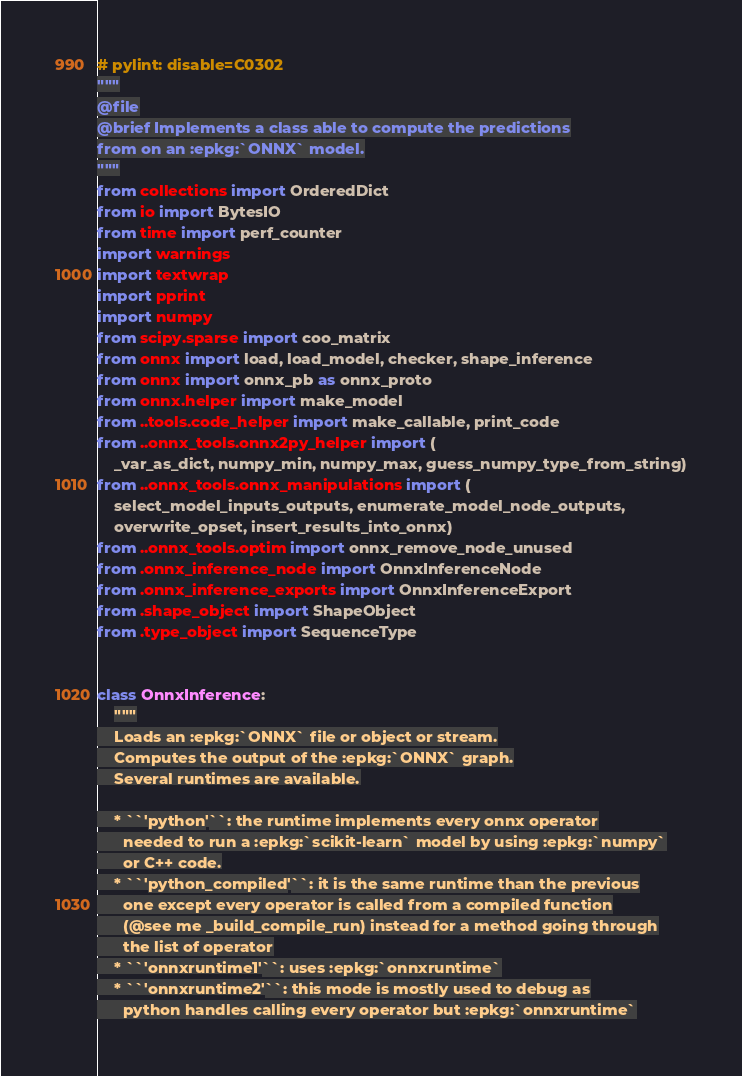<code> <loc_0><loc_0><loc_500><loc_500><_Python_># pylint: disable=C0302
"""
@file
@brief Implements a class able to compute the predictions
from on an :epkg:`ONNX` model.
"""
from collections import OrderedDict
from io import BytesIO
from time import perf_counter
import warnings
import textwrap
import pprint
import numpy
from scipy.sparse import coo_matrix
from onnx import load, load_model, checker, shape_inference
from onnx import onnx_pb as onnx_proto
from onnx.helper import make_model
from ..tools.code_helper import make_callable, print_code
from ..onnx_tools.onnx2py_helper import (
    _var_as_dict, numpy_min, numpy_max, guess_numpy_type_from_string)
from ..onnx_tools.onnx_manipulations import (
    select_model_inputs_outputs, enumerate_model_node_outputs,
    overwrite_opset, insert_results_into_onnx)
from ..onnx_tools.optim import onnx_remove_node_unused
from .onnx_inference_node import OnnxInferenceNode
from .onnx_inference_exports import OnnxInferenceExport
from .shape_object import ShapeObject
from .type_object import SequenceType


class OnnxInference:
    """
    Loads an :epkg:`ONNX` file or object or stream.
    Computes the output of the :epkg:`ONNX` graph.
    Several runtimes are available.

    * ``'python'``: the runtime implements every onnx operator
      needed to run a :epkg:`scikit-learn` model by using :epkg:`numpy`
      or C++ code.
    * ``'python_compiled'``: it is the same runtime than the previous
      one except every operator is called from a compiled function
      (@see me _build_compile_run) instead for a method going through
      the list of operator
    * ``'onnxruntime1'``: uses :epkg:`onnxruntime`
    * ``'onnxruntime2'``: this mode is mostly used to debug as
      python handles calling every operator but :epkg:`onnxruntime`</code> 